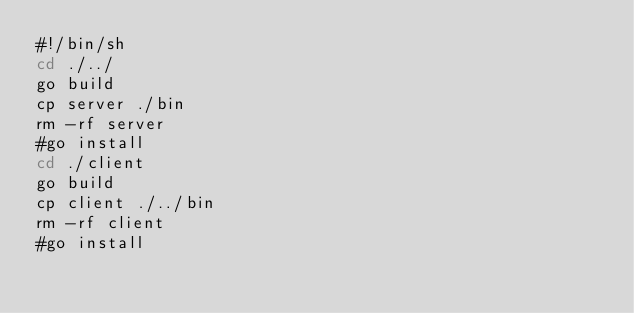Convert code to text. <code><loc_0><loc_0><loc_500><loc_500><_Bash_>#!/bin/sh
cd ./../
go build
cp server ./bin
rm -rf server
#go install
cd ./client
go build
cp client ./../bin
rm -rf client
#go install
</code> 